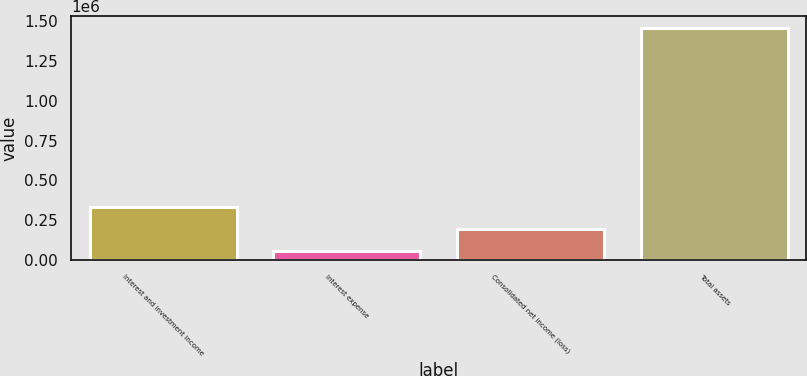Convert chart to OTSL. <chart><loc_0><loc_0><loc_500><loc_500><bar_chart><fcel>Interest and investment income<fcel>Interest expense<fcel>Consolidated net income (loss)<fcel>Total assets<nl><fcel>336541<fcel>56201<fcel>196371<fcel>1.4579e+06<nl></chart> 